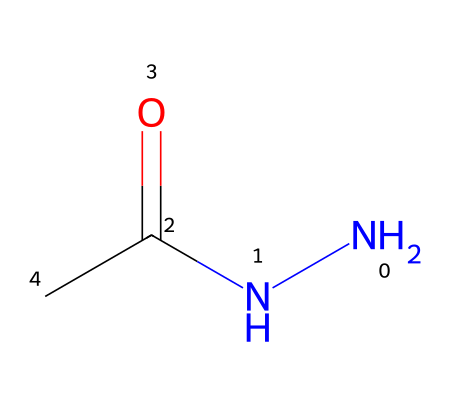How many nitrogen atoms are present in this chemical? The SMILES representation indicates the presence of two nitrogen atoms (N) in the hydrazine derivative structure. The notation 'N' appears twice, confirming the count.
Answer: two What is the functional group present in this chemical? The structure contains a carbonyl group (C=O) connected to a nitrogen, indicating the presence of an amide functional group (since it is N-C(=O)).
Answer: amide What is the total number of carbon atoms in this chemical? The SMILES shows one carbon atom connected to the carbonyl (C=O) and another distinct carbon connected to the nitrogen atoms, resulting in a total of two carbon atoms.
Answer: two How many bonds are formed between nitrogen and carbon in this structure? In this structure, one nitrogen atom is connected to one carbon atom through a single bond, and the second nitrogen forms a bond with the carbonyl carbon (double bond), totaling two bonds from nitrogen to carbon.
Answer: two What is the hybridization of the nitrogen atoms in this molecule? The nitrogen atoms in this structure appear to be sp2 hybridized due to their involvement in forming one sigma bond with carbon and a pi bond with the carbonyl oxygen (C=O). This sp2 configuration is consistent with a planar arrangement around nitrogen.
Answer: sp2 Is this molecule a hydrazine derivative? This compound features the NH2 (hydrazine) component along with a carbonyl group, confirming that it is indeed a derivative of hydrazine due to the presence of the distinct nitrogen structure.
Answer: yes 